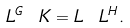<formula> <loc_0><loc_0><loc_500><loc_500>L ^ { G } \ K = L \ L ^ { H } .</formula> 